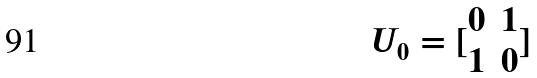<formula> <loc_0><loc_0><loc_500><loc_500>U _ { 0 } = [ \begin{matrix} 0 & 1 \\ 1 & 0 \end{matrix} ]</formula> 